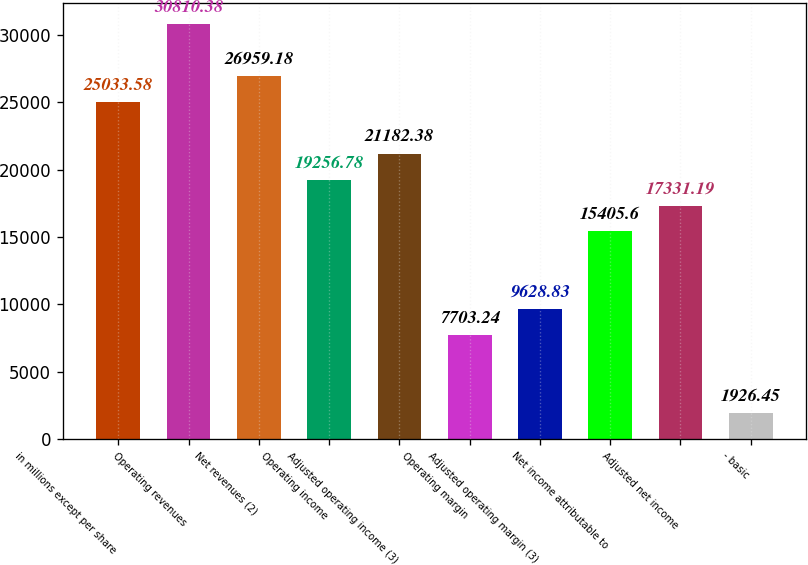<chart> <loc_0><loc_0><loc_500><loc_500><bar_chart><fcel>in millions except per share<fcel>Operating revenues<fcel>Net revenues (2)<fcel>Operating income<fcel>Adjusted operating income (3)<fcel>Operating margin<fcel>Adjusted operating margin (3)<fcel>Net income attributable to<fcel>Adjusted net income<fcel>- basic<nl><fcel>25033.6<fcel>30810.4<fcel>26959.2<fcel>19256.8<fcel>21182.4<fcel>7703.24<fcel>9628.83<fcel>15405.6<fcel>17331.2<fcel>1926.45<nl></chart> 